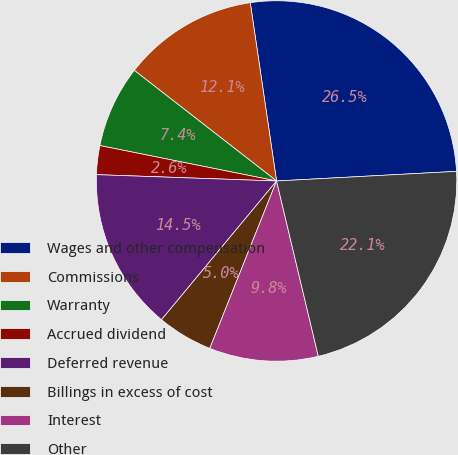Convert chart. <chart><loc_0><loc_0><loc_500><loc_500><pie_chart><fcel>Wages and other compensation<fcel>Commissions<fcel>Warranty<fcel>Accrued dividend<fcel>Deferred revenue<fcel>Billings in excess of cost<fcel>Interest<fcel>Other<nl><fcel>26.48%<fcel>12.15%<fcel>7.37%<fcel>2.59%<fcel>14.54%<fcel>4.98%<fcel>9.76%<fcel>22.13%<nl></chart> 